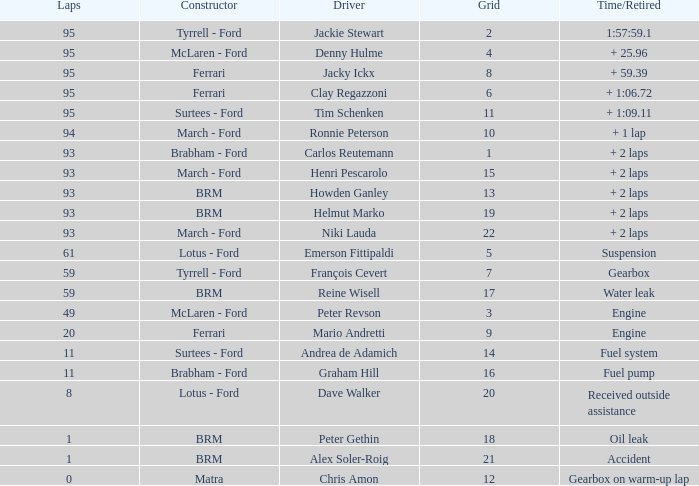How many grids does dave walker have? 1.0. 